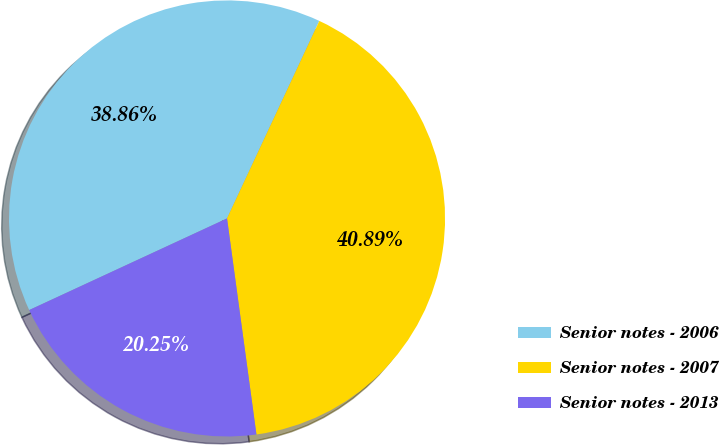<chart> <loc_0><loc_0><loc_500><loc_500><pie_chart><fcel>Senior notes - 2006<fcel>Senior notes - 2007<fcel>Senior notes - 2013<nl><fcel>38.86%<fcel>40.89%<fcel>20.25%<nl></chart> 